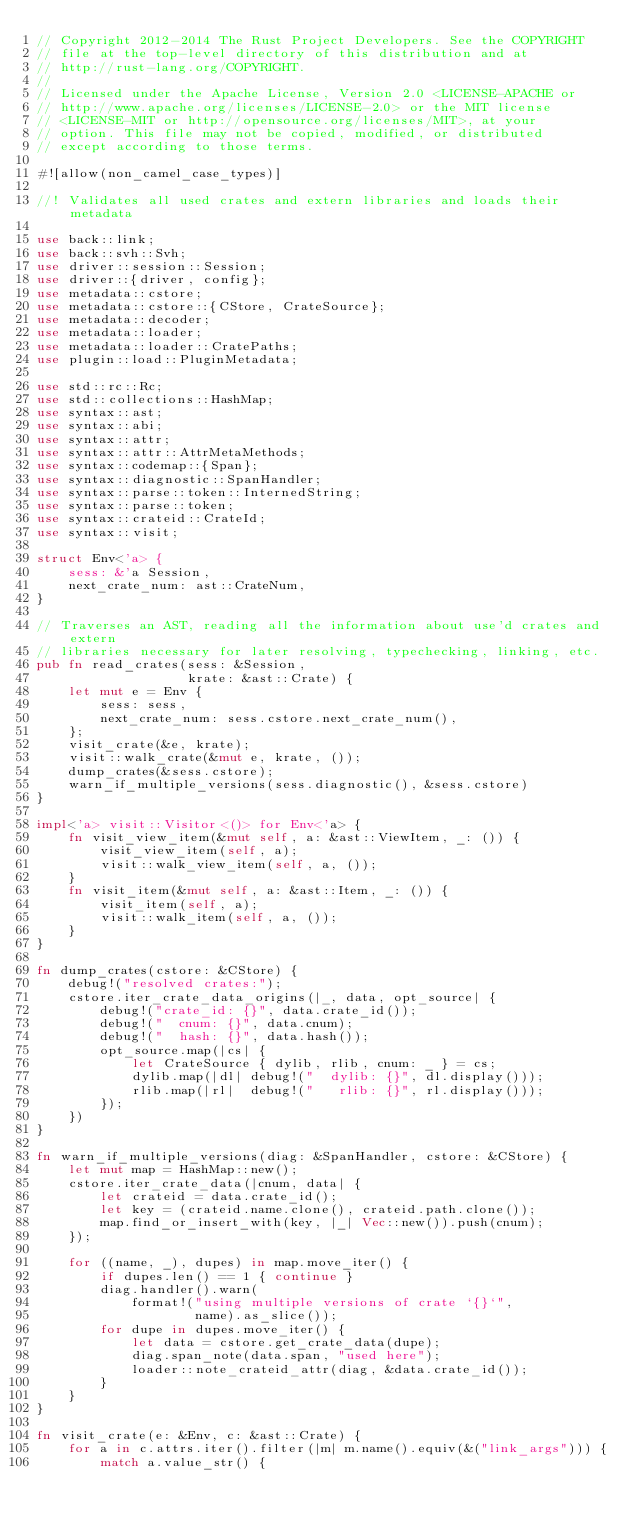Convert code to text. <code><loc_0><loc_0><loc_500><loc_500><_Rust_>// Copyright 2012-2014 The Rust Project Developers. See the COPYRIGHT
// file at the top-level directory of this distribution and at
// http://rust-lang.org/COPYRIGHT.
//
// Licensed under the Apache License, Version 2.0 <LICENSE-APACHE or
// http://www.apache.org/licenses/LICENSE-2.0> or the MIT license
// <LICENSE-MIT or http://opensource.org/licenses/MIT>, at your
// option. This file may not be copied, modified, or distributed
// except according to those terms.

#![allow(non_camel_case_types)]

//! Validates all used crates and extern libraries and loads their metadata

use back::link;
use back::svh::Svh;
use driver::session::Session;
use driver::{driver, config};
use metadata::cstore;
use metadata::cstore::{CStore, CrateSource};
use metadata::decoder;
use metadata::loader;
use metadata::loader::CratePaths;
use plugin::load::PluginMetadata;

use std::rc::Rc;
use std::collections::HashMap;
use syntax::ast;
use syntax::abi;
use syntax::attr;
use syntax::attr::AttrMetaMethods;
use syntax::codemap::{Span};
use syntax::diagnostic::SpanHandler;
use syntax::parse::token::InternedString;
use syntax::parse::token;
use syntax::crateid::CrateId;
use syntax::visit;

struct Env<'a> {
    sess: &'a Session,
    next_crate_num: ast::CrateNum,
}

// Traverses an AST, reading all the information about use'd crates and extern
// libraries necessary for later resolving, typechecking, linking, etc.
pub fn read_crates(sess: &Session,
                   krate: &ast::Crate) {
    let mut e = Env {
        sess: sess,
        next_crate_num: sess.cstore.next_crate_num(),
    };
    visit_crate(&e, krate);
    visit::walk_crate(&mut e, krate, ());
    dump_crates(&sess.cstore);
    warn_if_multiple_versions(sess.diagnostic(), &sess.cstore)
}

impl<'a> visit::Visitor<()> for Env<'a> {
    fn visit_view_item(&mut self, a: &ast::ViewItem, _: ()) {
        visit_view_item(self, a);
        visit::walk_view_item(self, a, ());
    }
    fn visit_item(&mut self, a: &ast::Item, _: ()) {
        visit_item(self, a);
        visit::walk_item(self, a, ());
    }
}

fn dump_crates(cstore: &CStore) {
    debug!("resolved crates:");
    cstore.iter_crate_data_origins(|_, data, opt_source| {
        debug!("crate_id: {}", data.crate_id());
        debug!("  cnum: {}", data.cnum);
        debug!("  hash: {}", data.hash());
        opt_source.map(|cs| {
            let CrateSource { dylib, rlib, cnum: _ } = cs;
            dylib.map(|dl| debug!("  dylib: {}", dl.display()));
            rlib.map(|rl|  debug!("   rlib: {}", rl.display()));
        });
    })
}

fn warn_if_multiple_versions(diag: &SpanHandler, cstore: &CStore) {
    let mut map = HashMap::new();
    cstore.iter_crate_data(|cnum, data| {
        let crateid = data.crate_id();
        let key = (crateid.name.clone(), crateid.path.clone());
        map.find_or_insert_with(key, |_| Vec::new()).push(cnum);
    });

    for ((name, _), dupes) in map.move_iter() {
        if dupes.len() == 1 { continue }
        diag.handler().warn(
            format!("using multiple versions of crate `{}`",
                    name).as_slice());
        for dupe in dupes.move_iter() {
            let data = cstore.get_crate_data(dupe);
            diag.span_note(data.span, "used here");
            loader::note_crateid_attr(diag, &data.crate_id());
        }
    }
}

fn visit_crate(e: &Env, c: &ast::Crate) {
    for a in c.attrs.iter().filter(|m| m.name().equiv(&("link_args"))) {
        match a.value_str() {</code> 